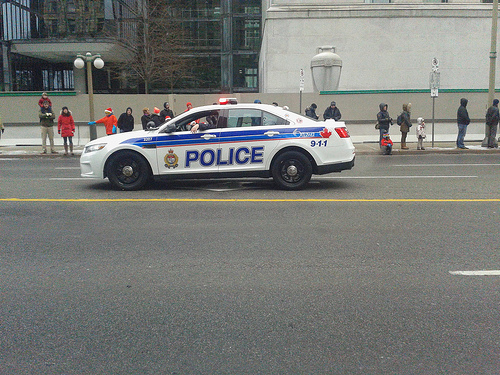<image>
Can you confirm if the police siren is above the door? Yes. The police siren is positioned above the door in the vertical space, higher up in the scene. 